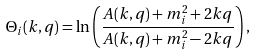<formula> <loc_0><loc_0><loc_500><loc_500>\Theta _ { i } ( k , q ) = \ln \left ( \frac { A ( k , q ) + m _ { i } ^ { 2 } + 2 k q } { A ( k , q ) + m _ { i } ^ { 2 } - 2 k q } \right ) ,</formula> 